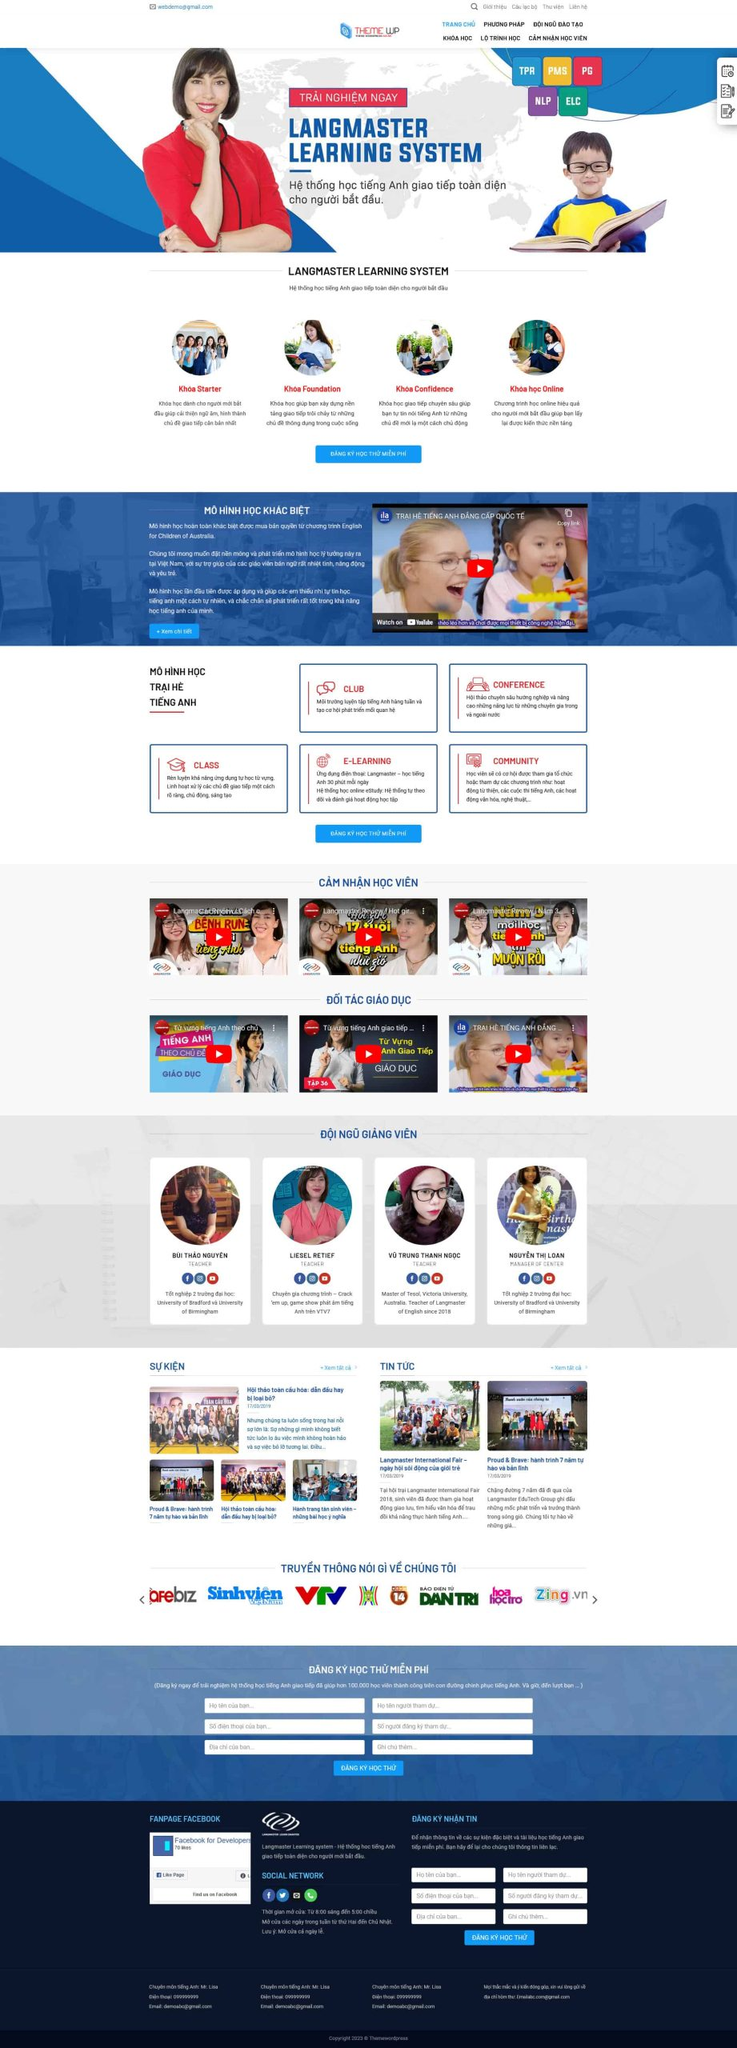Liệt kê 5 ngành nghề, lĩnh vực phù hợp với website này, phân cách các màu sắc bằng dấu phẩy. Chỉ trả về kết quả, phân cách bằng dấy phẩy
 Giáo dục, Khóa học, Tiếng Anh, Đào tạo, E-learning 